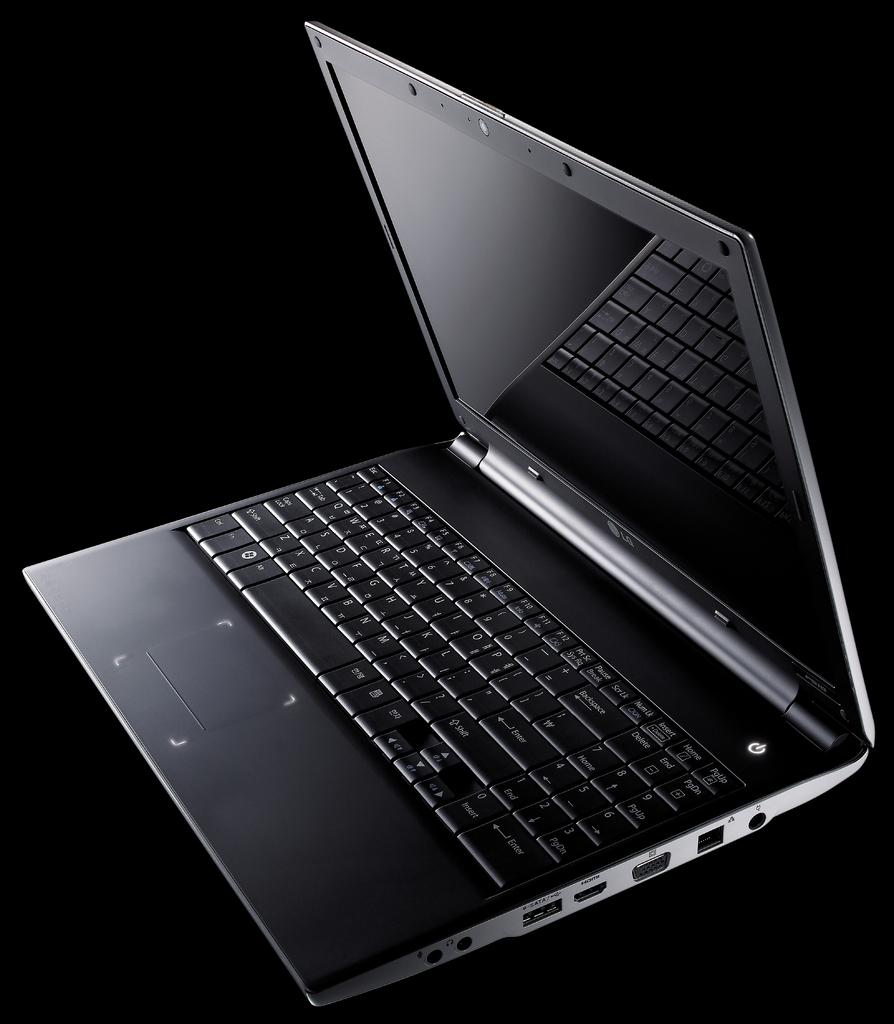<image>
Describe the image concisely. An LG portable lap top computer that is black and sleek 